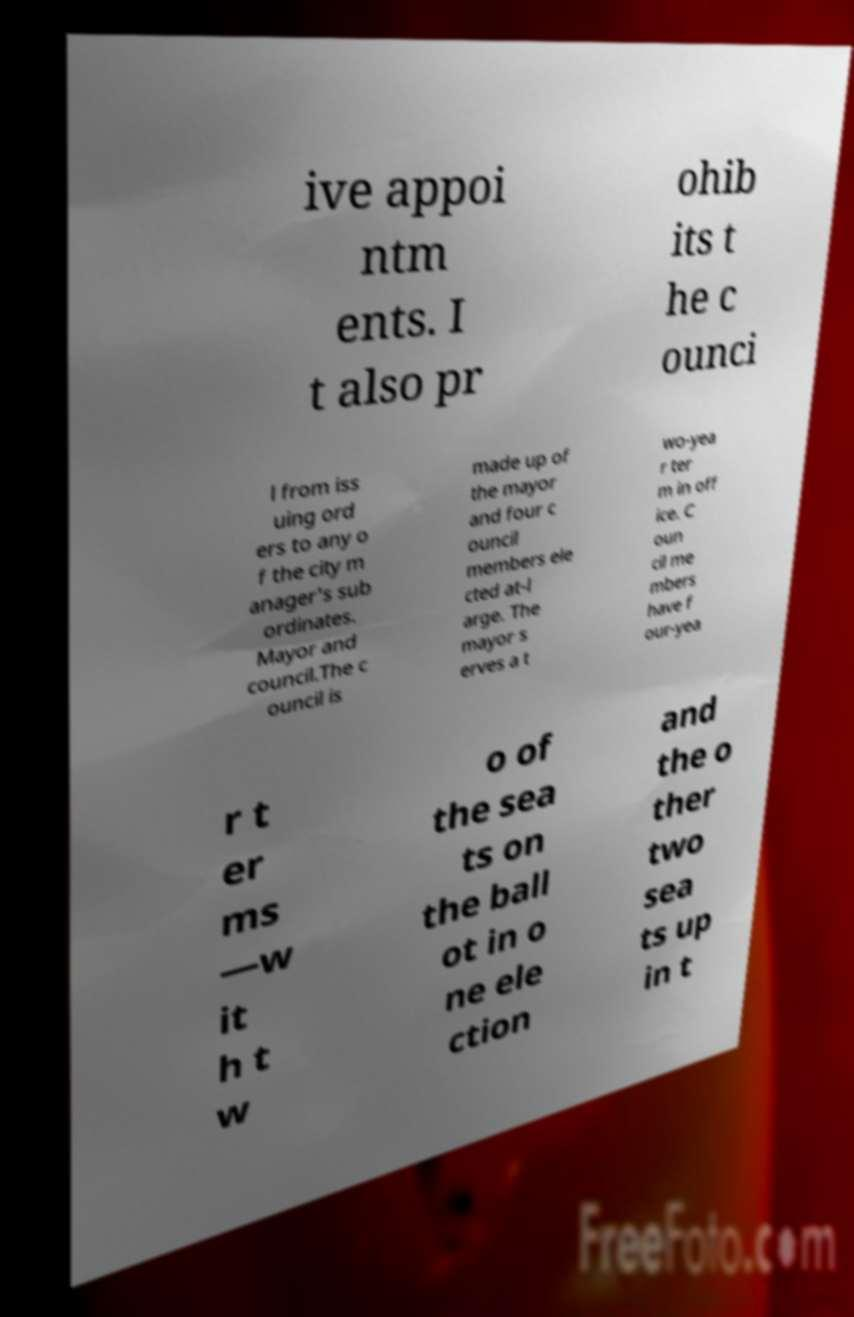Could you extract and type out the text from this image? ive appoi ntm ents. I t also pr ohib its t he c ounci l from iss uing ord ers to any o f the city m anager's sub ordinates. Mayor and council.The c ouncil is made up of the mayor and four c ouncil members ele cted at-l arge. The mayor s erves a t wo-yea r ter m in off ice. C oun cil me mbers have f our-yea r t er ms —w it h t w o of the sea ts on the ball ot in o ne ele ction and the o ther two sea ts up in t 